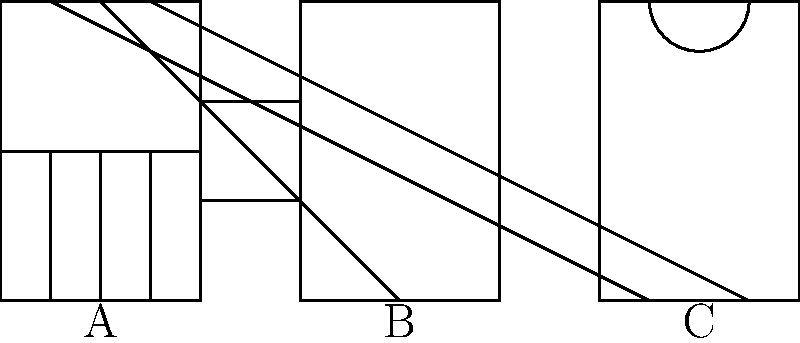Identify the architectural styles represented by the simplified facade sketches of famous Havana buildings labeled A, B, and C. Choose from: Colonial, Art Deco, and Neoclassical. To identify the architectural styles, let's analyze each facade sketch:

1. Facade A:
   - Rectangular shape with symmetrical layout
   - Three vertical divisions on the lower half
   - Horizontal division at mid-height
   These features are characteristic of Colonial architecture, common in Old Havana.

2. Facade B:
   - Rectangular shape with strong vertical emphasis
   - Central vertical division
   - Two horizontal divisions creating three equal sections
   These geometric patterns and emphasis on verticality are typical of Art Deco style, found in buildings from the 1920s and 1930s in Havana.

3. Facade C:
   - Rectangular shape with symmetrical layout
   - Arched top centerpiece
   - Two vertical divisions creating three sections
   The arched element and symmetrical columns are hallmarks of Neoclassical architecture, prevalent in many civic buildings in Havana.

Therefore, the architectural styles represented are:
A - Colonial
B - Art Deco
C - Neoclassical
Answer: A: Colonial, B: Art Deco, C: Neoclassical 